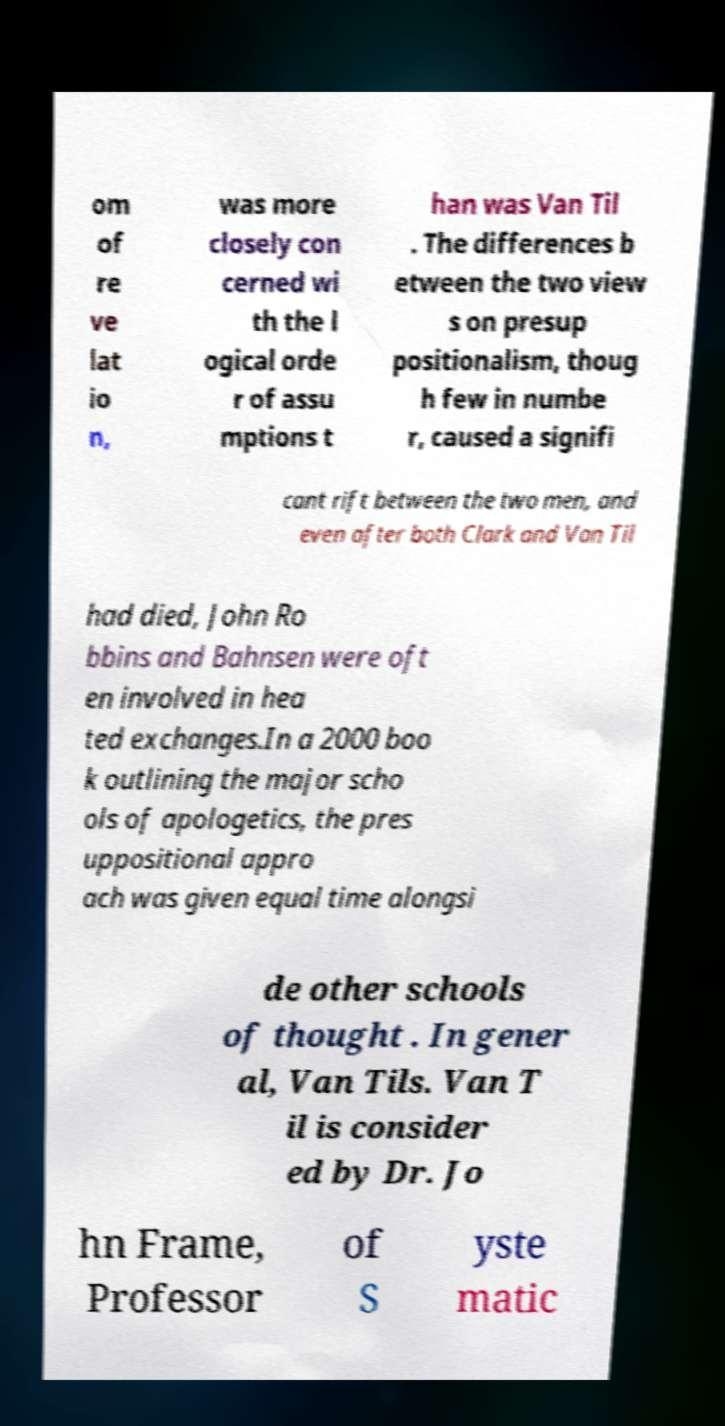Can you accurately transcribe the text from the provided image for me? om of re ve lat io n, was more closely con cerned wi th the l ogical orde r of assu mptions t han was Van Til . The differences b etween the two view s on presup positionalism, thoug h few in numbe r, caused a signifi cant rift between the two men, and even after both Clark and Van Til had died, John Ro bbins and Bahnsen were oft en involved in hea ted exchanges.In a 2000 boo k outlining the major scho ols of apologetics, the pres uppositional appro ach was given equal time alongsi de other schools of thought . In gener al, Van Tils. Van T il is consider ed by Dr. Jo hn Frame, Professor of S yste matic 